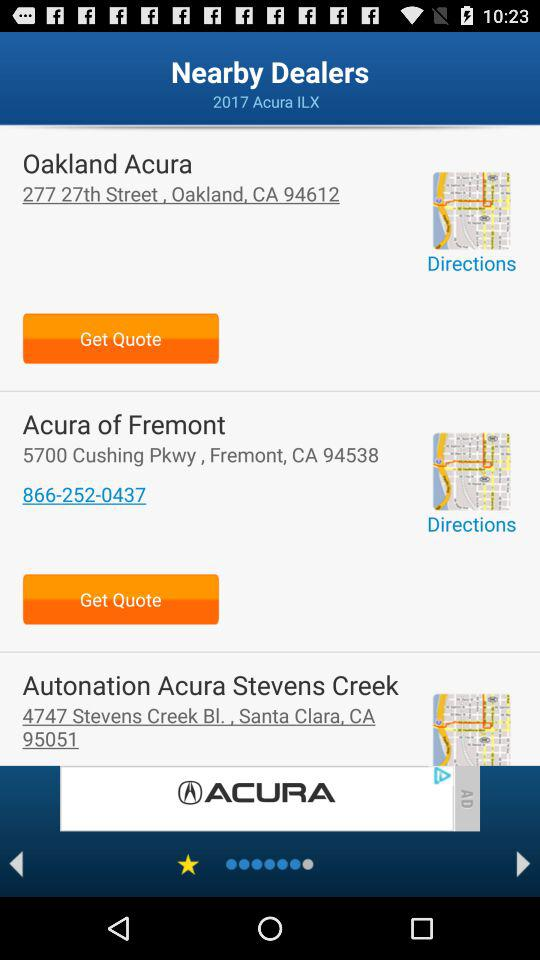What is the address of "Oakland Acura"? The address of "Oakland Acura" is 277 27th Street, Oakland, CA 94612. 